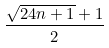Convert formula to latex. <formula><loc_0><loc_0><loc_500><loc_500>\frac { \sqrt { 2 4 n + 1 } + 1 } { 2 }</formula> 